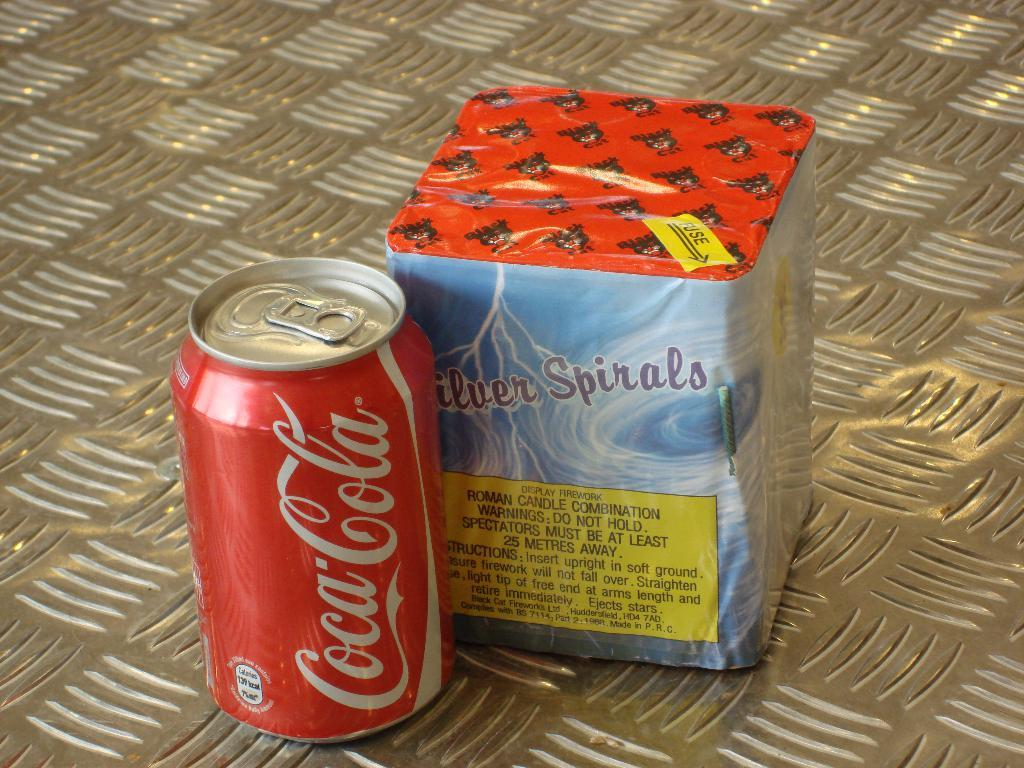<image>
Describe the image concisely. Coca cola can and some fireworks is sitting beside each other 